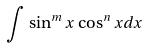<formula> <loc_0><loc_0><loc_500><loc_500>\int \sin ^ { m } x \cos ^ { n } x d x</formula> 